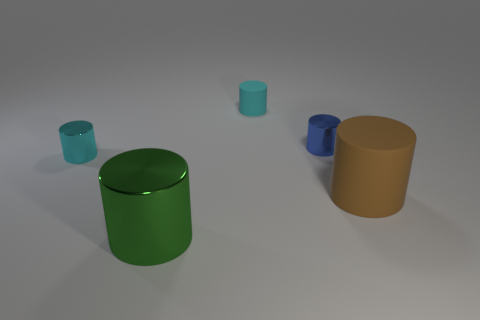There is a cyan object in front of the blue metal cylinder; is its size the same as the small rubber thing? Although the cyan object and the small rubber item share similarities in shape, their sizes are not identical. The cyan object is slightly larger as it stands with a greater height and width compared to the rubber object. 